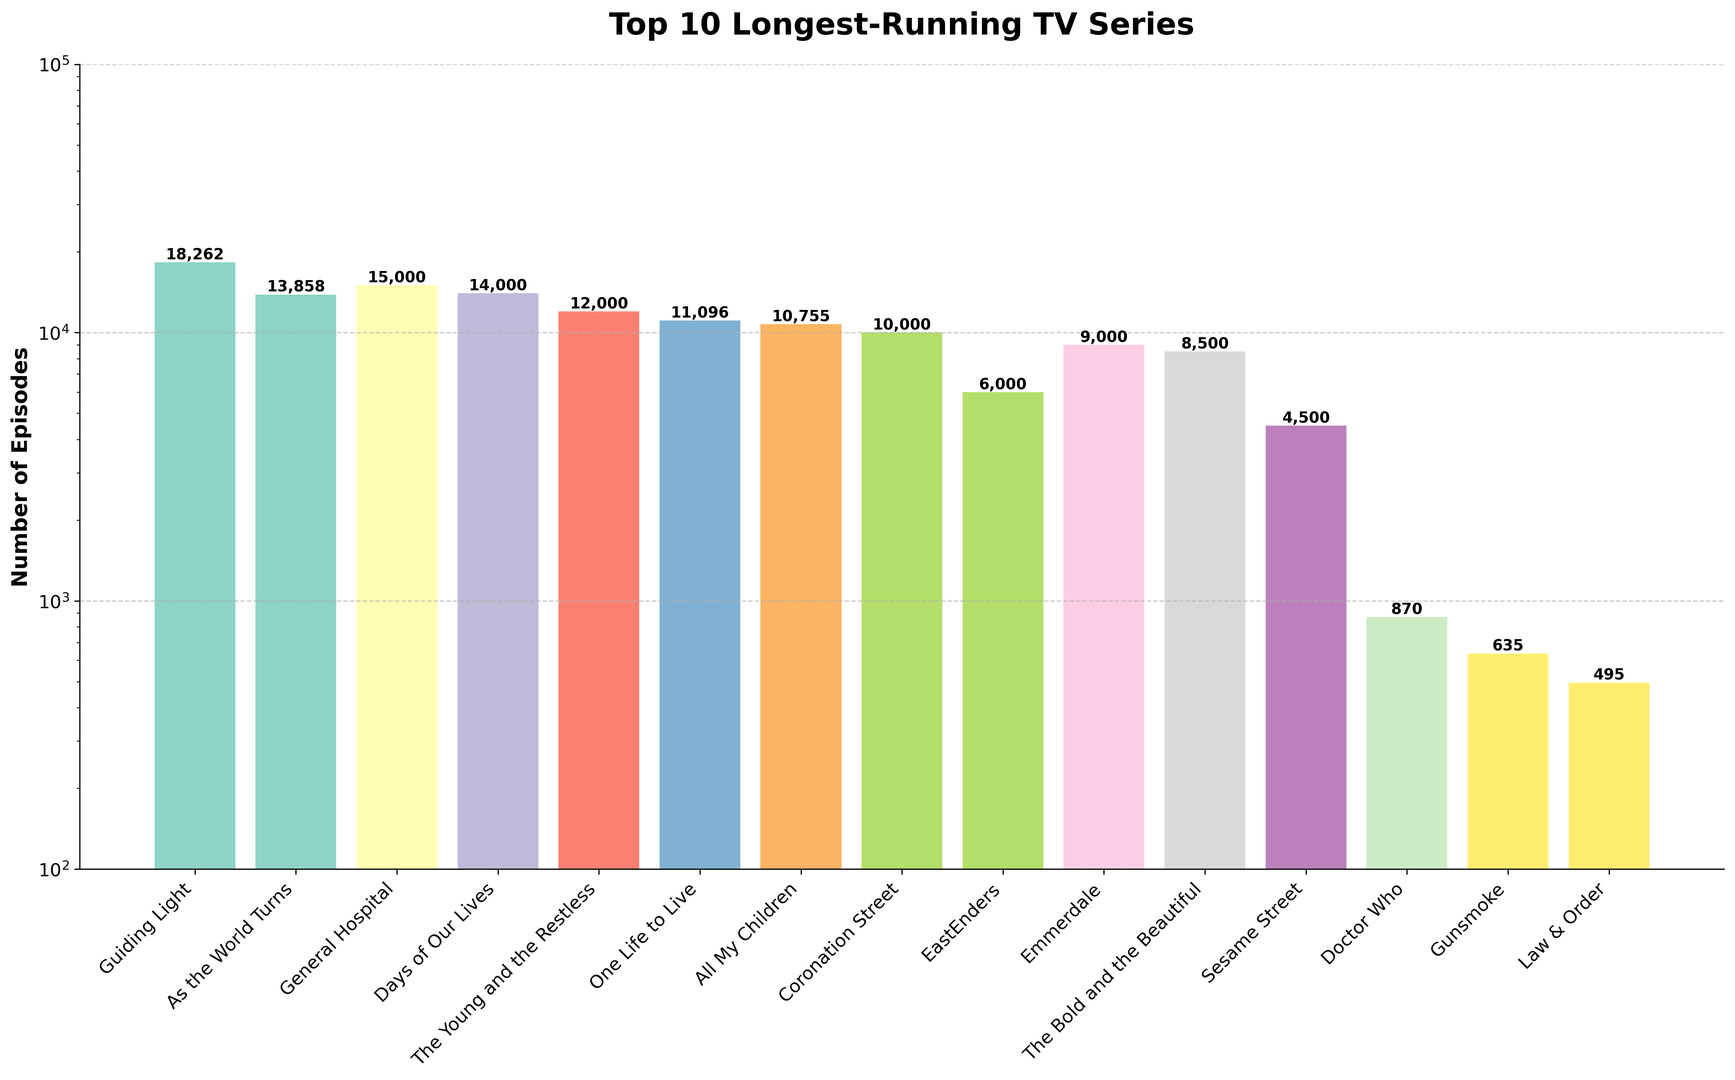Which TV series has the highest number of episodes? To find the TV series with the highest number of episodes, look at the bar with the greatest height.
Answer: Guiding Light What is the total number of episodes for the top three series combined (Guiding Light, As the World Turns, and General Hospital)? Add the episode counts for Guiding Light (18,262), As the World Turns (13,858), and General Hospital (15,000). 18,262 + 13,858 + 15,000 = 47,120
Answer: 47,120 Is the number of episodes for EastEnders greater than 50% of the episodes of Coronation Street? Calculate 50% of the episodes of Coronation Street (10,000 / 2 = 5,000). Compare this to the number of episodes of EastEnders (6,000). Since 6,000 > 5,000, the answer is yes.
Answer: Yes How many more episodes does The Bold and the Beautiful have compared to Gunsmoke? Subtract the number of episodes of Gunsmoke (635) from the number of episodes of The Bold and the Beautiful (8,500). 8,500 - 635 = 7,865
Answer: 7,865 Rank the series from longest-running to shortest-running based on the number of episodes. List the series in descending order by their episode count: Guiding Light, General Hospital, Days of Our Lives, As the World Turns, The Young and the Restless, One Life to Live, All My Children, Coronation Street, Emmerdale, EastEnders.
Answer: Guiding Light, General Hospital, Days of Our Lives, As the World Turns, The Young and the Restless, One Life to Live, All My Children, Coronation Street, Emmerdale, EastEnders Which series has almost half the number of episodes as Guiding Light? Calculate half of Guiding Light's episodes (18,262 / 2 = 9,131). Compare this to the other episode counts. Emmerdale (9,000) is closest to this value.
Answer: Emmerdale What is the range of episodes spanned by these series? Subtract the lowest episode count (495 for Law & Order) from the highest episode count (18,262 for Guiding Light). 18,262 - 495 = 17,767
Answer: 17,767 Are there more series with fewer than 10,000 episodes or series with more than 10,000 episodes? Count the number of series with fewer than 10,000 episodes (Doctor Who, Gunsmoke, Law & Order, The Bold and the Beautiful, EastEnders, Emmerdale = 6). Count the number of series with more than 10,000 episodes (Guiding Light, As the World Turns, General Hospital, Days of Our Lives, The Young and the Restless, One Life to Live, All My Children, Coronation Street = 8). 8 > 6, so there are more with more than 10,000 episodes.
Answer: More series with more than 10,000 episodes 